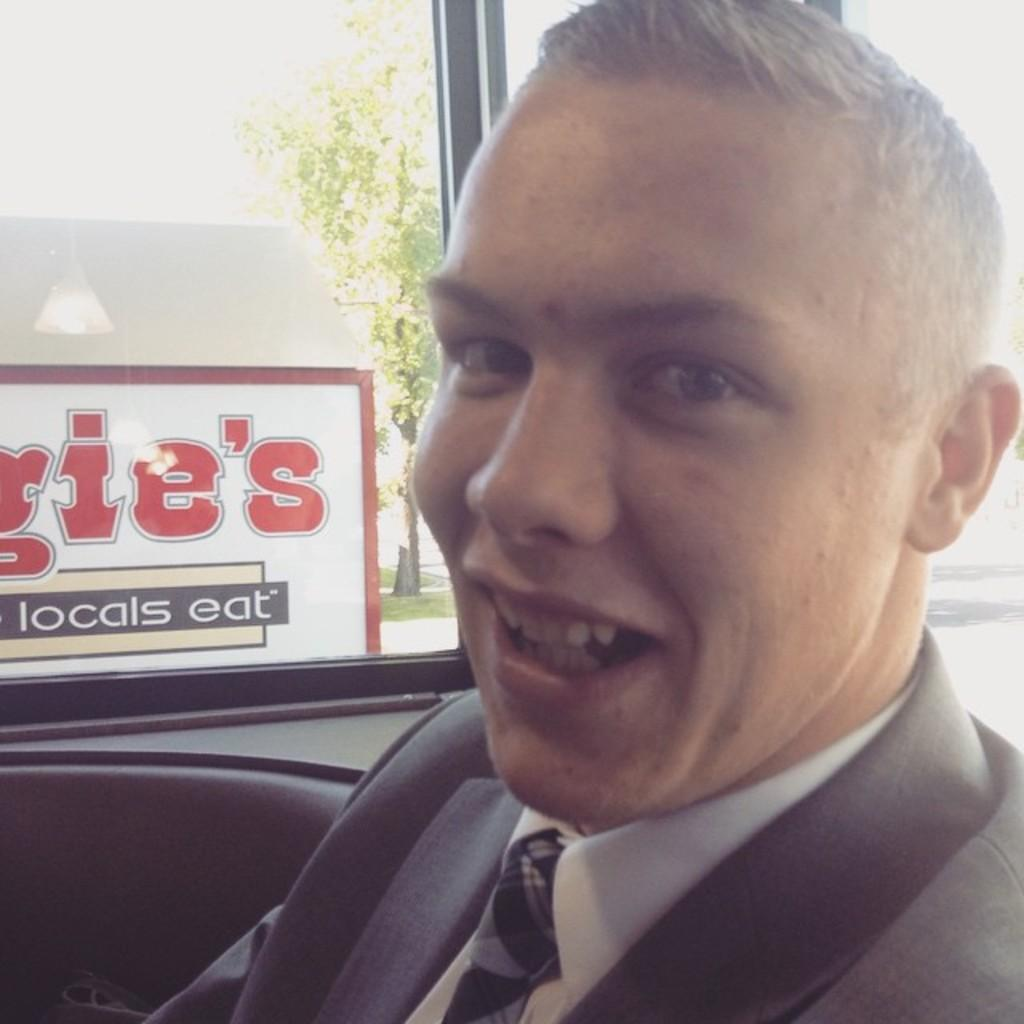What is the person in the image doing? There is a person sitting in the image. What type of structure is visible in the image? There is a glass window in the image. What is on the glass window? A poster is visible on the glass window. What type of caption is written on the person's hair in the image? There is no caption written on the person's hair in the image, nor is there any indication that the person's hair is visible. 